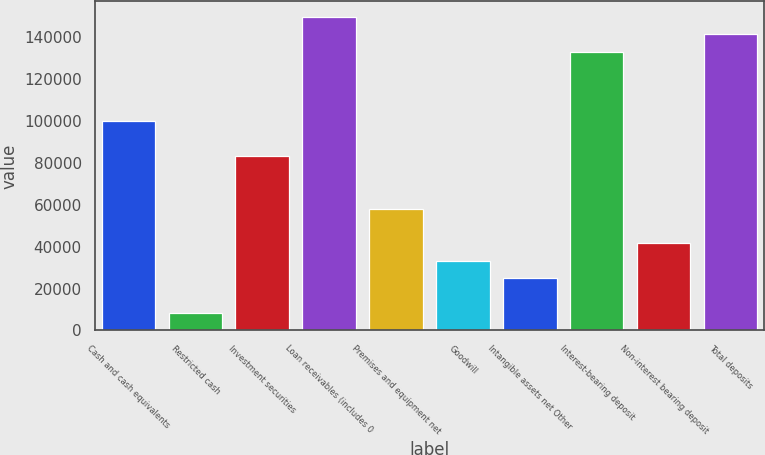Convert chart. <chart><loc_0><loc_0><loc_500><loc_500><bar_chart><fcel>Cash and cash equivalents<fcel>Restricted cash<fcel>Investment securities<fcel>Loan receivables (includes 0<fcel>Premises and equipment net<fcel>Goodwill<fcel>Intangible assets net Other<fcel>Interest-bearing deposit<fcel>Non-interest bearing deposit<fcel>Total deposits<nl><fcel>99750.2<fcel>8317.1<fcel>83126<fcel>149623<fcel>58189.7<fcel>33253.4<fcel>24941.3<fcel>132999<fcel>41565.5<fcel>141311<nl></chart> 